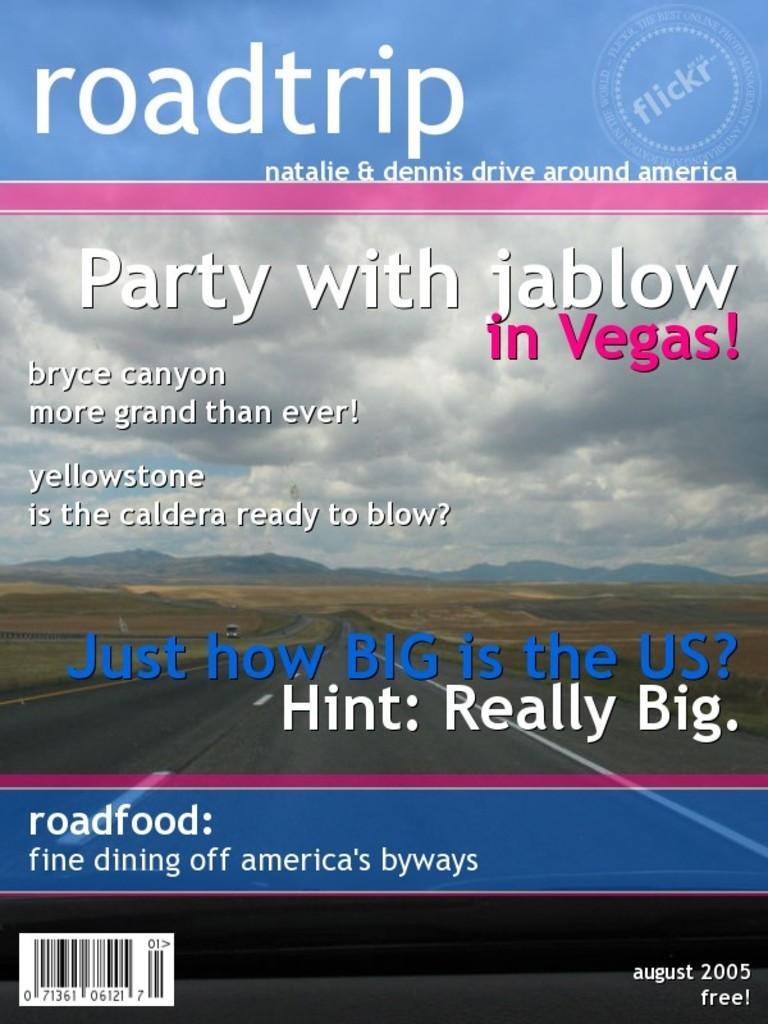<image>
Provide a brief description of the given image. The free August 2005 edition of Roadtrip magazine featuring Natalie & Dennis who drive around America. 